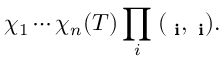Convert formula to latex. <formula><loc_0><loc_0><loc_500><loc_500>\chi _ { 1 } \cdots \chi _ { n } ( T ) \prod _ { i } \, ( { \Psi _ { i } } , { \Phi _ { i } } ) .</formula> 